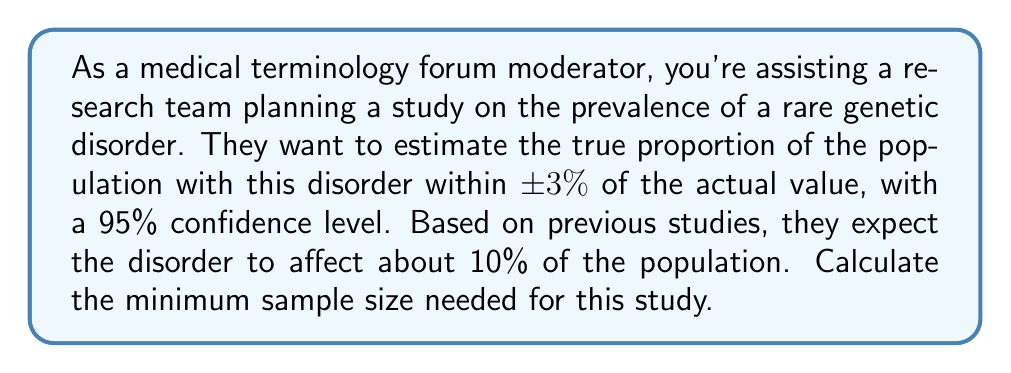Could you help me with this problem? To calculate the sample size needed for a desired confidence level in a medical study, we'll use the following formula:

$$n = \frac{z^2 \cdot p(1-p)}{E^2}$$

Where:
$n$ = required sample size
$z$ = z-score for the desired confidence level
$p$ = expected proportion
$E$ = margin of error (as a decimal)

Step 1: Determine the z-score for a 95% confidence level.
For a 95% confidence level, $z = 1.96$

Step 2: Convert the margin of error to a decimal.
$E = 3\% = 0.03$

Step 3: Use the expected proportion.
$p = 10\% = 0.10$

Step 4: Plug the values into the formula:

$$n = \frac{1.96^2 \cdot 0.10(1-0.10)}{0.03^2}$$

Step 5: Calculate:

$$n = \frac{3.8416 \cdot 0.10 \cdot 0.90}{0.0009}$$

$$n = \frac{0.345744}{0.0009} = 384.16$$

Step 6: Round up to the nearest whole number, as we can't have a fractional sample size.

$n = 385$

Therefore, the minimum sample size needed for this study is 385 participants.
Answer: 385 participants 